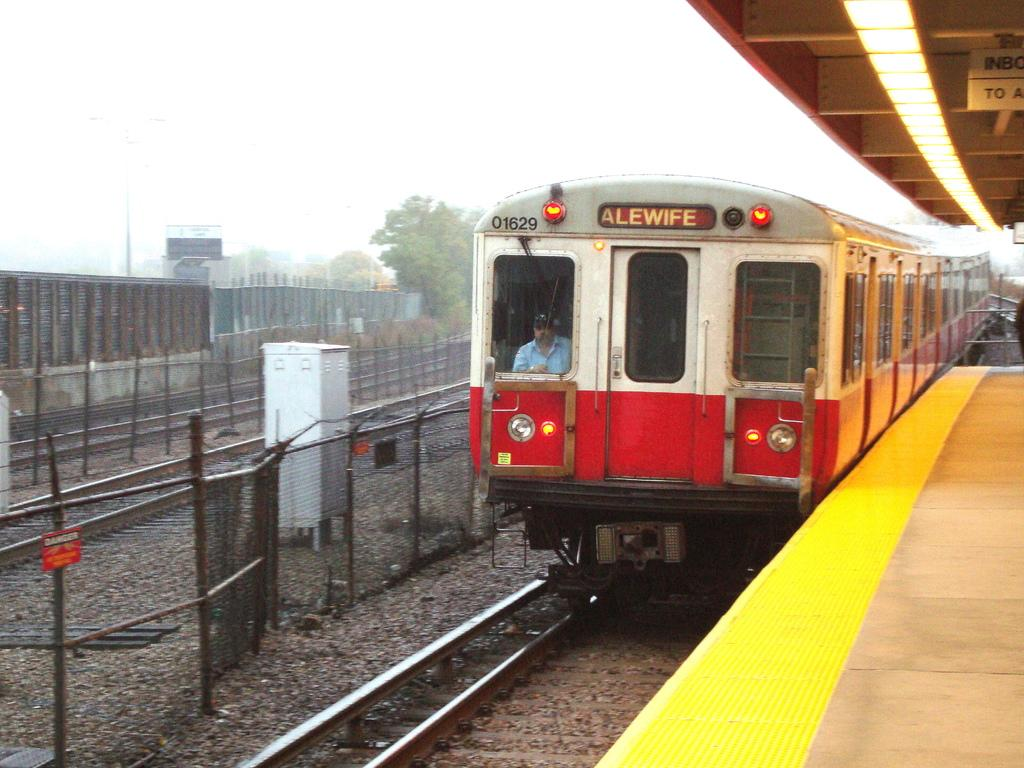<image>
Create a compact narrative representing the image presented. A red and white train has the word alewife on its top. 